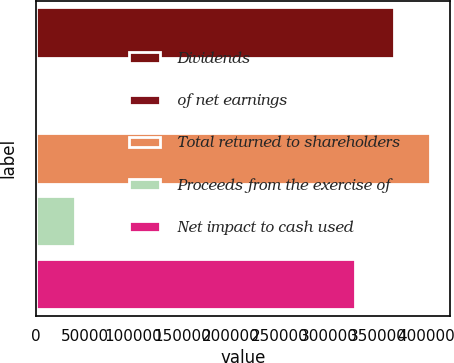Convert chart to OTSL. <chart><loc_0><loc_0><loc_500><loc_500><bar_chart><fcel>Dividends<fcel>of net earnings<fcel>Total returned to shareholders<fcel>Proceeds from the exercise of<fcel>Net impact to cash used<nl><fcel>367306<fcel>87.3<fcel>404028<fcel>39793<fcel>327513<nl></chart> 